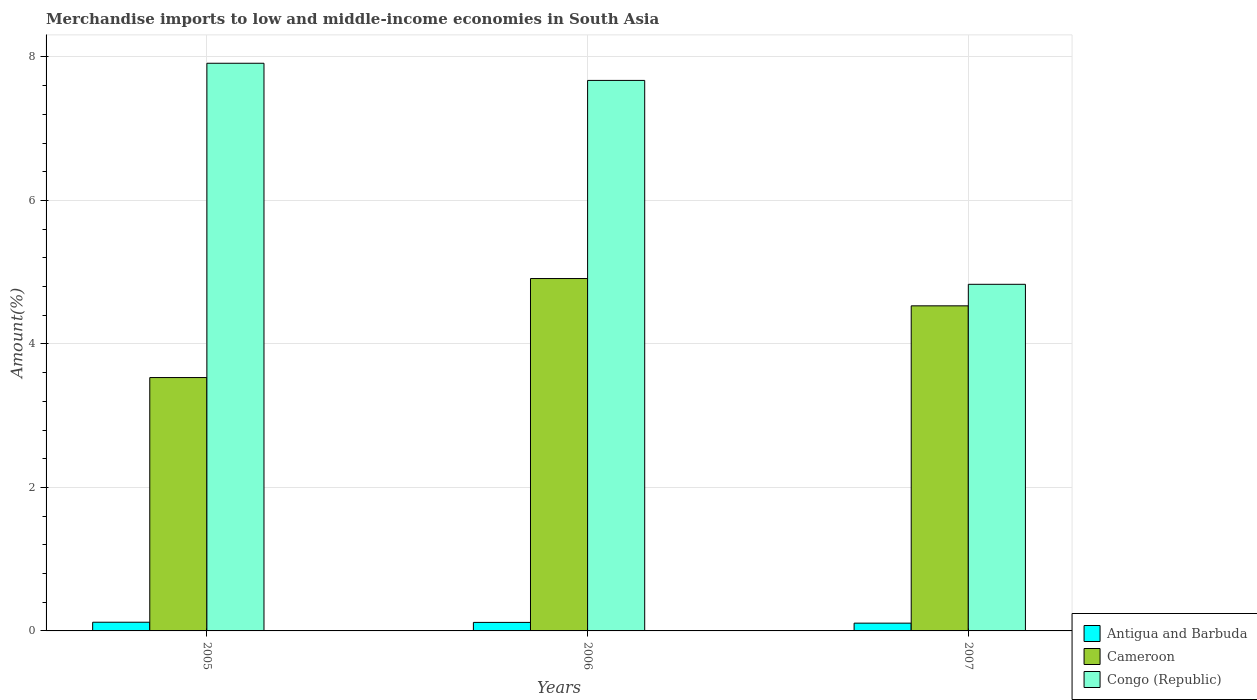Are the number of bars per tick equal to the number of legend labels?
Your answer should be very brief. Yes. Are the number of bars on each tick of the X-axis equal?
Your answer should be compact. Yes. How many bars are there on the 3rd tick from the right?
Provide a succinct answer. 3. What is the percentage of amount earned from merchandise imports in Cameroon in 2005?
Keep it short and to the point. 3.53. Across all years, what is the maximum percentage of amount earned from merchandise imports in Antigua and Barbuda?
Ensure brevity in your answer.  0.12. Across all years, what is the minimum percentage of amount earned from merchandise imports in Cameroon?
Offer a very short reply. 3.53. In which year was the percentage of amount earned from merchandise imports in Antigua and Barbuda maximum?
Give a very brief answer. 2005. In which year was the percentage of amount earned from merchandise imports in Antigua and Barbuda minimum?
Your response must be concise. 2007. What is the total percentage of amount earned from merchandise imports in Cameroon in the graph?
Provide a succinct answer. 12.97. What is the difference between the percentage of amount earned from merchandise imports in Congo (Republic) in 2006 and that in 2007?
Ensure brevity in your answer.  2.84. What is the difference between the percentage of amount earned from merchandise imports in Antigua and Barbuda in 2007 and the percentage of amount earned from merchandise imports in Congo (Republic) in 2005?
Offer a terse response. -7.8. What is the average percentage of amount earned from merchandise imports in Congo (Republic) per year?
Provide a succinct answer. 6.8. In the year 2006, what is the difference between the percentage of amount earned from merchandise imports in Cameroon and percentage of amount earned from merchandise imports in Antigua and Barbuda?
Your answer should be very brief. 4.79. What is the ratio of the percentage of amount earned from merchandise imports in Antigua and Barbuda in 2005 to that in 2007?
Ensure brevity in your answer.  1.12. What is the difference between the highest and the second highest percentage of amount earned from merchandise imports in Antigua and Barbuda?
Give a very brief answer. 0. What is the difference between the highest and the lowest percentage of amount earned from merchandise imports in Antigua and Barbuda?
Your response must be concise. 0.01. In how many years, is the percentage of amount earned from merchandise imports in Antigua and Barbuda greater than the average percentage of amount earned from merchandise imports in Antigua and Barbuda taken over all years?
Provide a succinct answer. 2. What does the 2nd bar from the left in 2007 represents?
Make the answer very short. Cameroon. What does the 2nd bar from the right in 2005 represents?
Ensure brevity in your answer.  Cameroon. How many bars are there?
Offer a very short reply. 9. How many years are there in the graph?
Your response must be concise. 3. What is the difference between two consecutive major ticks on the Y-axis?
Provide a succinct answer. 2. Does the graph contain any zero values?
Your answer should be compact. No. Does the graph contain grids?
Offer a terse response. Yes. Where does the legend appear in the graph?
Give a very brief answer. Bottom right. How many legend labels are there?
Provide a short and direct response. 3. How are the legend labels stacked?
Give a very brief answer. Vertical. What is the title of the graph?
Keep it short and to the point. Merchandise imports to low and middle-income economies in South Asia. Does "Least developed countries" appear as one of the legend labels in the graph?
Keep it short and to the point. No. What is the label or title of the X-axis?
Provide a short and direct response. Years. What is the label or title of the Y-axis?
Ensure brevity in your answer.  Amount(%). What is the Amount(%) of Antigua and Barbuda in 2005?
Your response must be concise. 0.12. What is the Amount(%) in Cameroon in 2005?
Ensure brevity in your answer.  3.53. What is the Amount(%) of Congo (Republic) in 2005?
Keep it short and to the point. 7.91. What is the Amount(%) of Antigua and Barbuda in 2006?
Keep it short and to the point. 0.12. What is the Amount(%) in Cameroon in 2006?
Your answer should be very brief. 4.91. What is the Amount(%) of Congo (Republic) in 2006?
Offer a terse response. 7.67. What is the Amount(%) in Antigua and Barbuda in 2007?
Your answer should be compact. 0.11. What is the Amount(%) in Cameroon in 2007?
Provide a succinct answer. 4.53. What is the Amount(%) in Congo (Republic) in 2007?
Keep it short and to the point. 4.83. Across all years, what is the maximum Amount(%) in Antigua and Barbuda?
Give a very brief answer. 0.12. Across all years, what is the maximum Amount(%) of Cameroon?
Give a very brief answer. 4.91. Across all years, what is the maximum Amount(%) in Congo (Republic)?
Offer a very short reply. 7.91. Across all years, what is the minimum Amount(%) of Antigua and Barbuda?
Offer a terse response. 0.11. Across all years, what is the minimum Amount(%) of Cameroon?
Ensure brevity in your answer.  3.53. Across all years, what is the minimum Amount(%) in Congo (Republic)?
Make the answer very short. 4.83. What is the total Amount(%) in Antigua and Barbuda in the graph?
Your response must be concise. 0.35. What is the total Amount(%) of Cameroon in the graph?
Your answer should be very brief. 12.97. What is the total Amount(%) in Congo (Republic) in the graph?
Offer a terse response. 20.41. What is the difference between the Amount(%) in Antigua and Barbuda in 2005 and that in 2006?
Make the answer very short. 0. What is the difference between the Amount(%) in Cameroon in 2005 and that in 2006?
Your response must be concise. -1.38. What is the difference between the Amount(%) in Congo (Republic) in 2005 and that in 2006?
Offer a very short reply. 0.24. What is the difference between the Amount(%) in Antigua and Barbuda in 2005 and that in 2007?
Provide a short and direct response. 0.01. What is the difference between the Amount(%) in Cameroon in 2005 and that in 2007?
Your response must be concise. -1. What is the difference between the Amount(%) in Congo (Republic) in 2005 and that in 2007?
Offer a terse response. 3.08. What is the difference between the Amount(%) in Antigua and Barbuda in 2006 and that in 2007?
Offer a very short reply. 0.01. What is the difference between the Amount(%) in Cameroon in 2006 and that in 2007?
Ensure brevity in your answer.  0.38. What is the difference between the Amount(%) of Congo (Republic) in 2006 and that in 2007?
Keep it short and to the point. 2.84. What is the difference between the Amount(%) in Antigua and Barbuda in 2005 and the Amount(%) in Cameroon in 2006?
Offer a very short reply. -4.79. What is the difference between the Amount(%) of Antigua and Barbuda in 2005 and the Amount(%) of Congo (Republic) in 2006?
Your response must be concise. -7.55. What is the difference between the Amount(%) of Cameroon in 2005 and the Amount(%) of Congo (Republic) in 2006?
Keep it short and to the point. -4.14. What is the difference between the Amount(%) in Antigua and Barbuda in 2005 and the Amount(%) in Cameroon in 2007?
Ensure brevity in your answer.  -4.41. What is the difference between the Amount(%) of Antigua and Barbuda in 2005 and the Amount(%) of Congo (Republic) in 2007?
Provide a succinct answer. -4.71. What is the difference between the Amount(%) of Cameroon in 2005 and the Amount(%) of Congo (Republic) in 2007?
Provide a short and direct response. -1.3. What is the difference between the Amount(%) of Antigua and Barbuda in 2006 and the Amount(%) of Cameroon in 2007?
Ensure brevity in your answer.  -4.41. What is the difference between the Amount(%) of Antigua and Barbuda in 2006 and the Amount(%) of Congo (Republic) in 2007?
Your answer should be very brief. -4.71. What is the difference between the Amount(%) in Cameroon in 2006 and the Amount(%) in Congo (Republic) in 2007?
Ensure brevity in your answer.  0.08. What is the average Amount(%) of Antigua and Barbuda per year?
Your response must be concise. 0.12. What is the average Amount(%) in Cameroon per year?
Make the answer very short. 4.32. What is the average Amount(%) of Congo (Republic) per year?
Make the answer very short. 6.8. In the year 2005, what is the difference between the Amount(%) of Antigua and Barbuda and Amount(%) of Cameroon?
Keep it short and to the point. -3.41. In the year 2005, what is the difference between the Amount(%) of Antigua and Barbuda and Amount(%) of Congo (Republic)?
Your answer should be compact. -7.79. In the year 2005, what is the difference between the Amount(%) of Cameroon and Amount(%) of Congo (Republic)?
Ensure brevity in your answer.  -4.38. In the year 2006, what is the difference between the Amount(%) of Antigua and Barbuda and Amount(%) of Cameroon?
Provide a short and direct response. -4.79. In the year 2006, what is the difference between the Amount(%) of Antigua and Barbuda and Amount(%) of Congo (Republic)?
Provide a succinct answer. -7.55. In the year 2006, what is the difference between the Amount(%) of Cameroon and Amount(%) of Congo (Republic)?
Offer a very short reply. -2.76. In the year 2007, what is the difference between the Amount(%) of Antigua and Barbuda and Amount(%) of Cameroon?
Your response must be concise. -4.42. In the year 2007, what is the difference between the Amount(%) of Antigua and Barbuda and Amount(%) of Congo (Republic)?
Give a very brief answer. -4.72. In the year 2007, what is the difference between the Amount(%) in Cameroon and Amount(%) in Congo (Republic)?
Your answer should be compact. -0.3. What is the ratio of the Amount(%) in Antigua and Barbuda in 2005 to that in 2006?
Provide a succinct answer. 1.02. What is the ratio of the Amount(%) of Cameroon in 2005 to that in 2006?
Offer a very short reply. 0.72. What is the ratio of the Amount(%) in Congo (Republic) in 2005 to that in 2006?
Offer a very short reply. 1.03. What is the ratio of the Amount(%) in Antigua and Barbuda in 2005 to that in 2007?
Ensure brevity in your answer.  1.12. What is the ratio of the Amount(%) in Cameroon in 2005 to that in 2007?
Offer a very short reply. 0.78. What is the ratio of the Amount(%) of Congo (Republic) in 2005 to that in 2007?
Your response must be concise. 1.64. What is the ratio of the Amount(%) of Antigua and Barbuda in 2006 to that in 2007?
Your answer should be very brief. 1.1. What is the ratio of the Amount(%) in Cameroon in 2006 to that in 2007?
Your answer should be very brief. 1.08. What is the ratio of the Amount(%) of Congo (Republic) in 2006 to that in 2007?
Your response must be concise. 1.59. What is the difference between the highest and the second highest Amount(%) of Antigua and Barbuda?
Your answer should be compact. 0. What is the difference between the highest and the second highest Amount(%) in Cameroon?
Offer a very short reply. 0.38. What is the difference between the highest and the second highest Amount(%) of Congo (Republic)?
Your answer should be very brief. 0.24. What is the difference between the highest and the lowest Amount(%) in Antigua and Barbuda?
Give a very brief answer. 0.01. What is the difference between the highest and the lowest Amount(%) of Cameroon?
Offer a very short reply. 1.38. What is the difference between the highest and the lowest Amount(%) in Congo (Republic)?
Give a very brief answer. 3.08. 